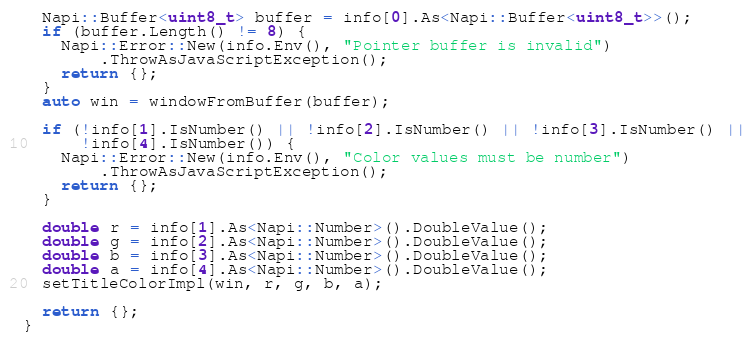<code> <loc_0><loc_0><loc_500><loc_500><_ObjectiveC_>
  Napi::Buffer<uint8_t> buffer = info[0].As<Napi::Buffer<uint8_t>>();
  if (buffer.Length() != 8) {
    Napi::Error::New(info.Env(), "Pointer buffer is invalid")
        .ThrowAsJavaScriptException();
    return {};
  }
  auto win = windowFromBuffer(buffer);

  if (!info[1].IsNumber() || !info[2].IsNumber() || !info[3].IsNumber() ||
      !info[4].IsNumber()) {
    Napi::Error::New(info.Env(), "Color values must be number")
        .ThrowAsJavaScriptException();
    return {};
  }

  double r = info[1].As<Napi::Number>().DoubleValue();
  double g = info[2].As<Napi::Number>().DoubleValue();
  double b = info[3].As<Napi::Number>().DoubleValue();
  double a = info[4].As<Napi::Number>().DoubleValue();
  setTitleColorImpl(win, r, g, b, a);

  return {};
}
</code> 